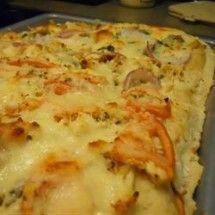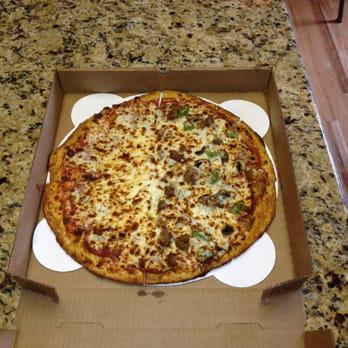The first image is the image on the left, the second image is the image on the right. Considering the images on both sides, is "The left image shows a rectangular metal tray containing something that is mostly yellow." valid? Answer yes or no. Yes. 